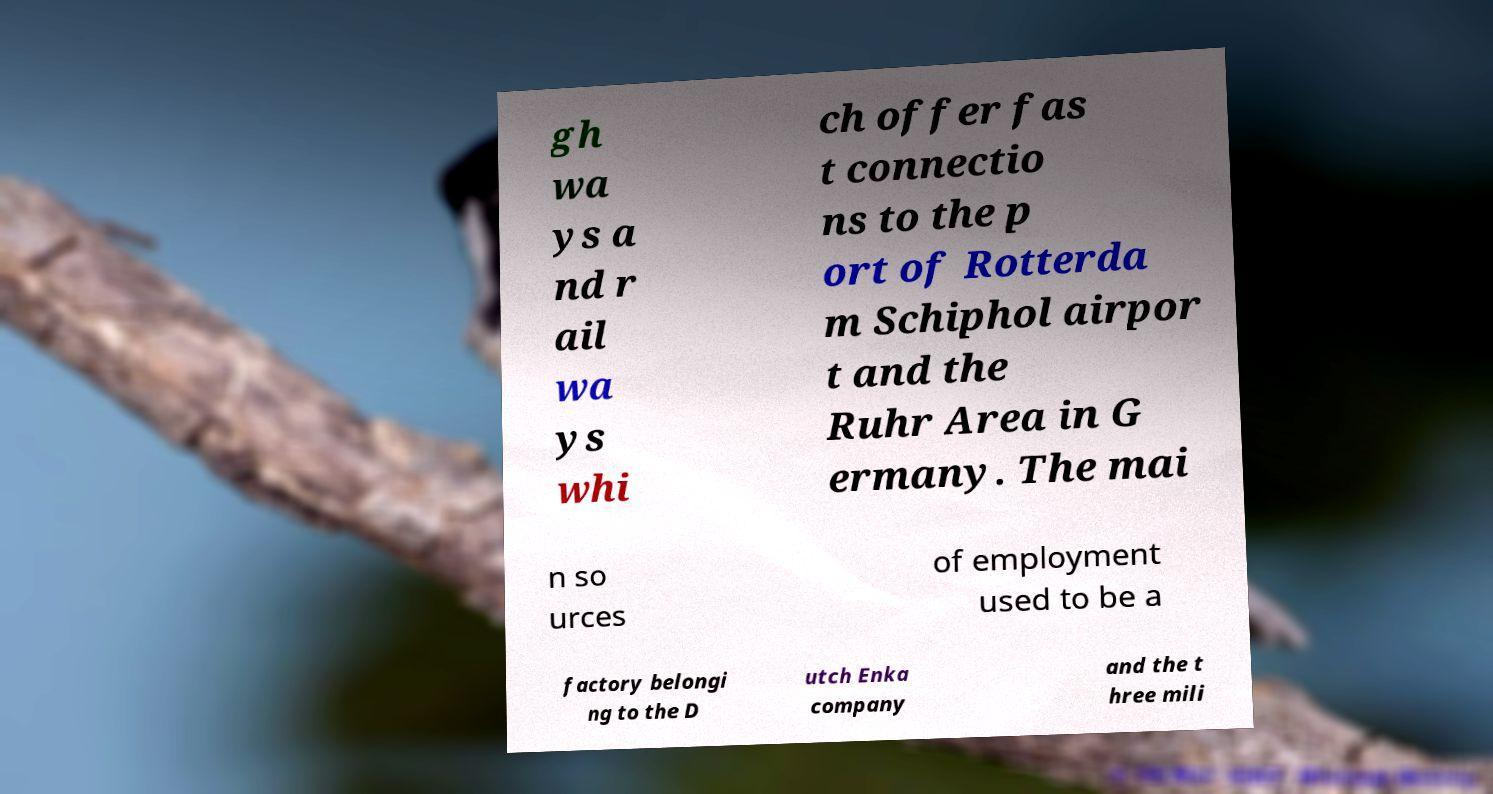Please read and relay the text visible in this image. What does it say? gh wa ys a nd r ail wa ys whi ch offer fas t connectio ns to the p ort of Rotterda m Schiphol airpor t and the Ruhr Area in G ermany. The mai n so urces of employment used to be a factory belongi ng to the D utch Enka company and the t hree mili 